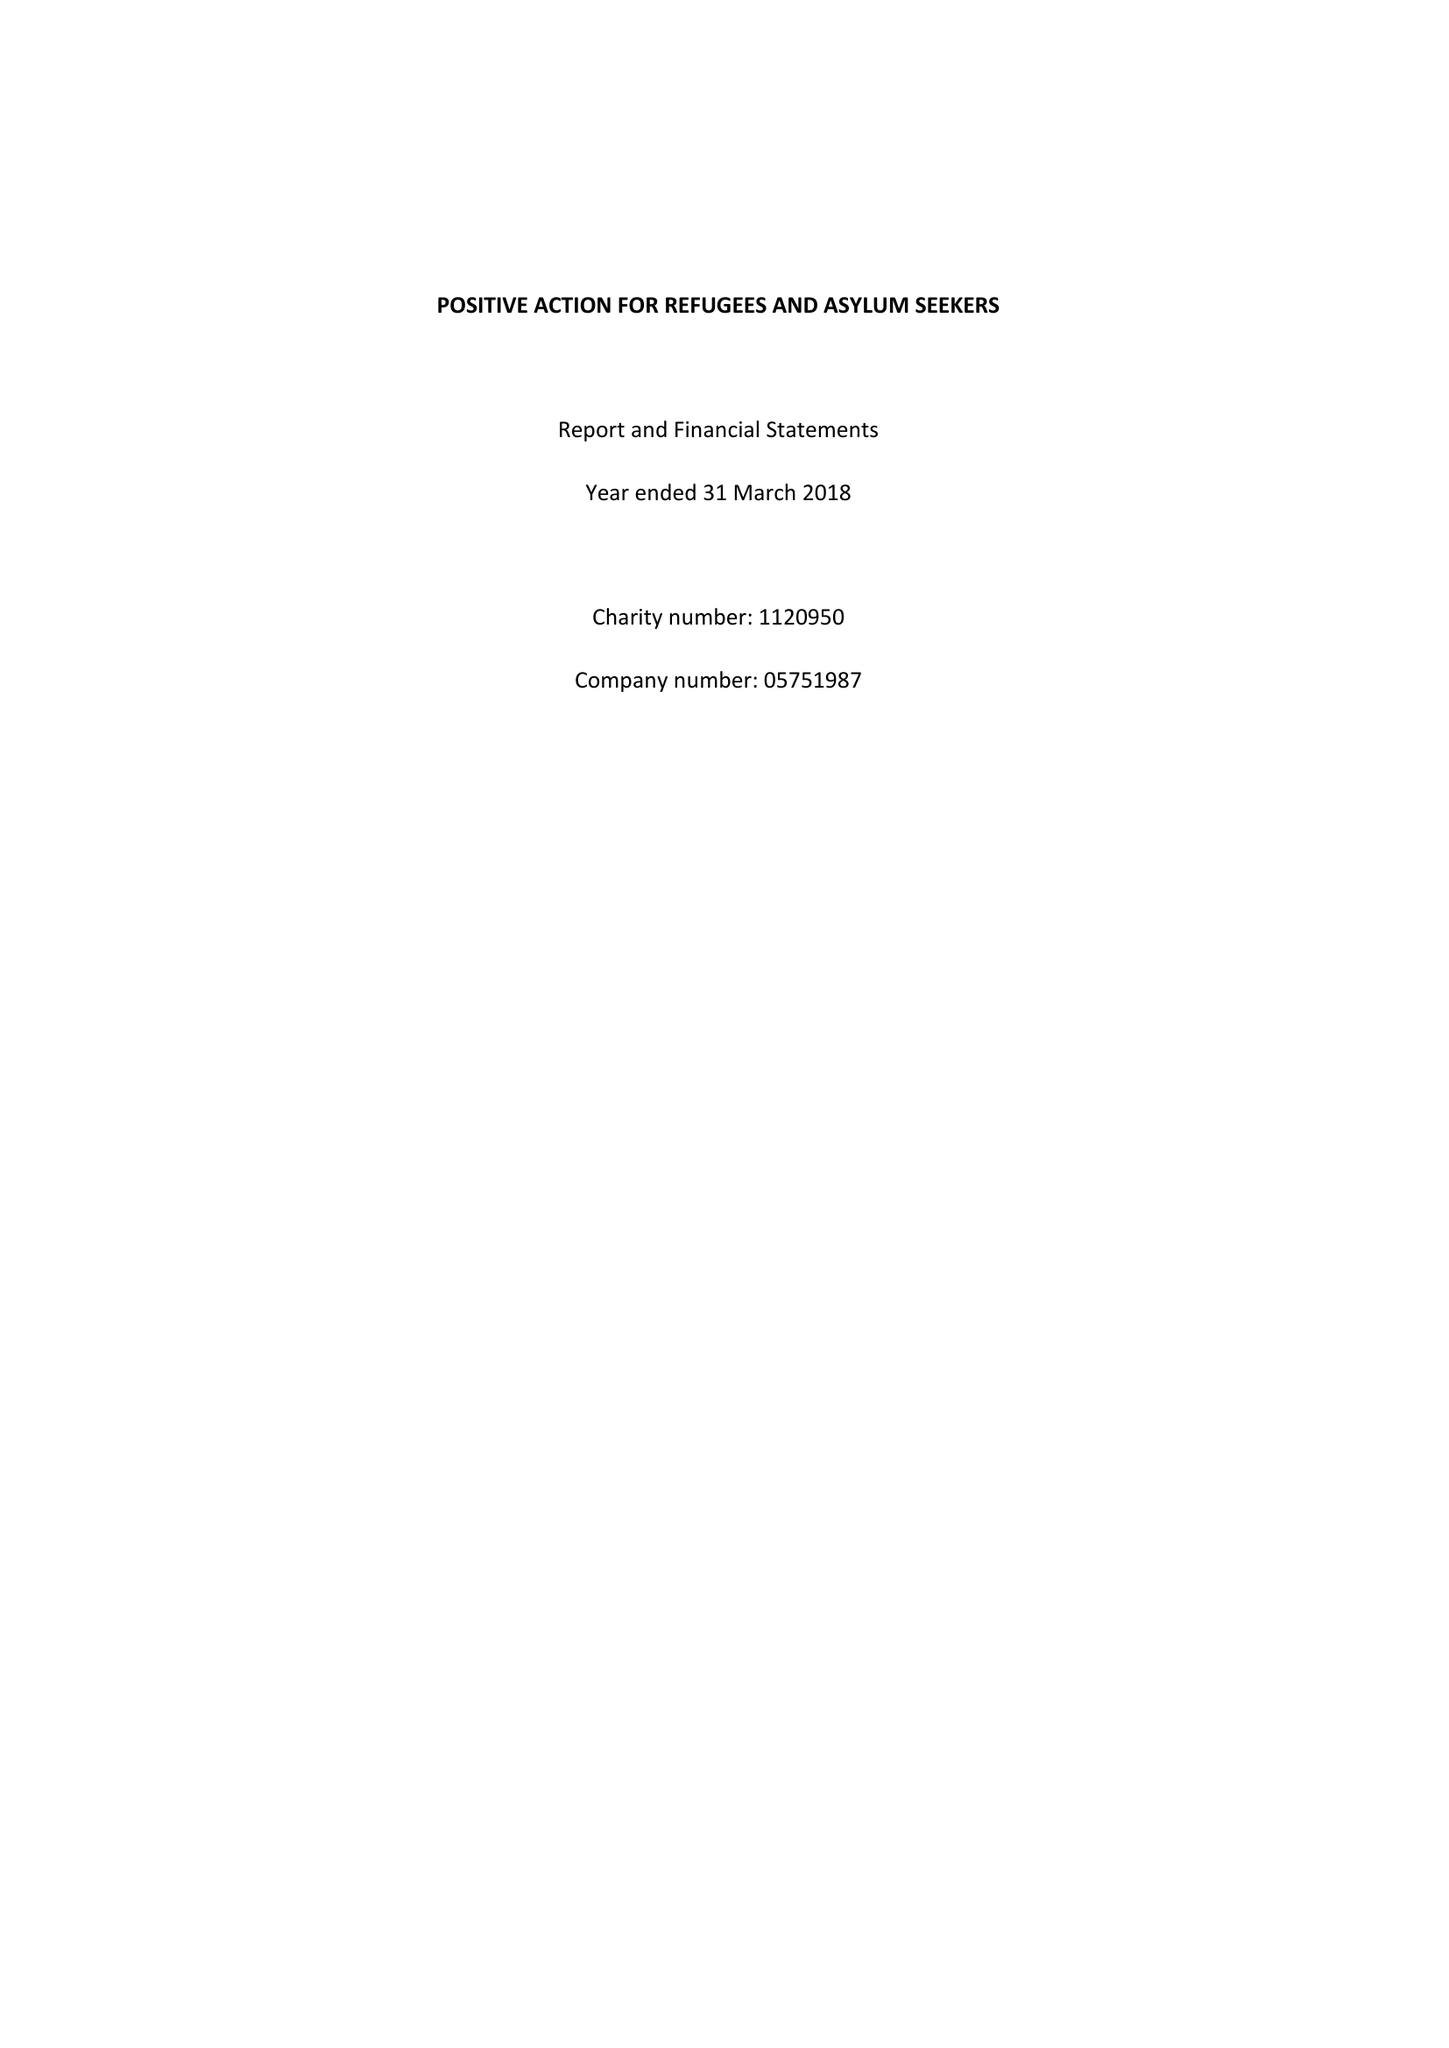What is the value for the charity_number?
Answer the question using a single word or phrase. 1120950 